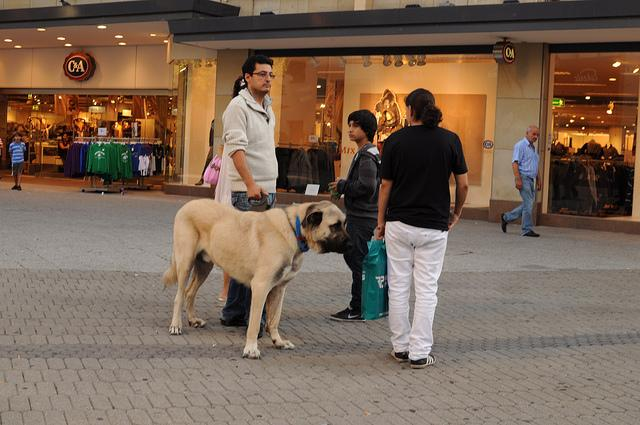What activity are the people shown involved in? Please explain your reasoning. shopping. The people are in an outdoor mall. 